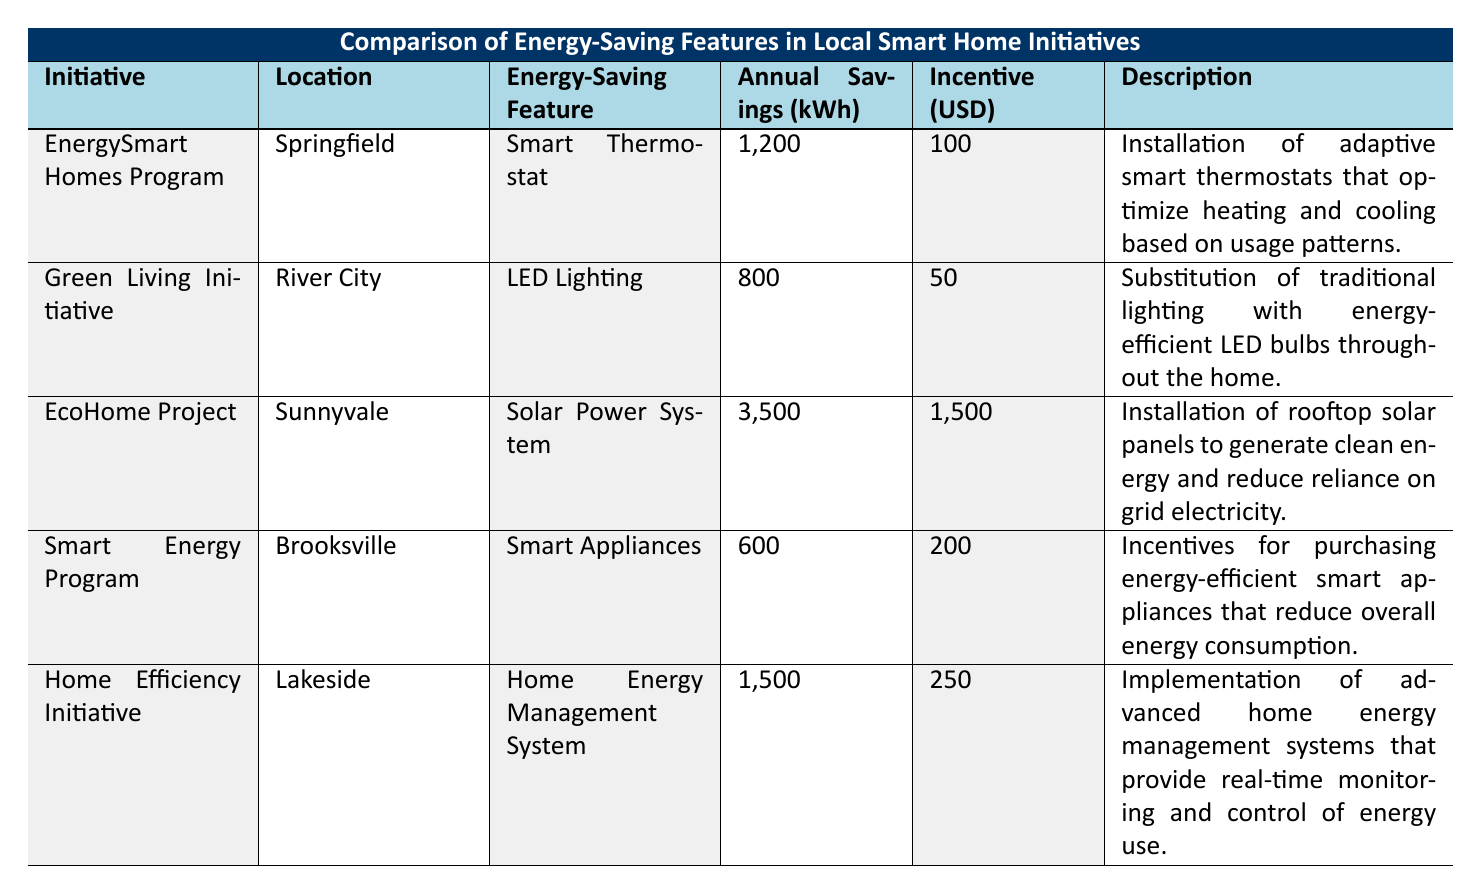What is the annual energy savings for the EcoHome Project? The table shows that the EcoHome Project provides annual savings of 3500 kWh.
Answer: 3500 kWh Which location has the highest incentive amount? By comparing the incentive amounts listed, the EcoHome Project in Sunnyvale offers the highest incentive of 1500 USD.
Answer: Sunnyvale How much energy savings is achieved by the Home Efficiency Initiative compared to the Smart Energy Program? The Home Efficiency Initiative saves 1500 kWh, while the Smart Energy Program saves 600 kWh. The difference is 1500 - 600 = 900 kWh.
Answer: 900 kWh Is the annual savings for the Green Living Initiative less than 1000 kWh? The annual savings for the Green Living Initiative is 800 kWh, which is indeed less than 1000 kWh.
Answer: Yes What is the average annual savings of the energy-saving features listed in the table? The total annual savings are 1200 + 800 + 3500 + 600 + 1500 = 6600 kWh. There are 5 initiatives, so the average is 6600 / 5 = 1320 kWh.
Answer: 1320 kWh Does the Smart Appliances feature offer the least annual savings? The Smart Appliances feature offers annual savings of 600 kWh, which is less than any other feature listed in the table.
Answer: Yes What is the total amount of incentives for all initiatives combined? Adding up the incentives: 100 + 50 + 1500 + 200 + 250 = 2100 USD gives the total incentive amount.
Answer: 2100 USD Which initiative offers a home energy management system? The Home Efficiency Initiative provides a Home Energy Management System as its energy-saving feature.
Answer: Home Efficiency Initiative How many initiatives listed provide an annual saving of more than 1000 kWh? The initiatives that save more than 1000 kWh are the EcoHome Project (3500 kWh) and the Home Efficiency Initiative (1500 kWh). Thus, there are 2 such initiatives.
Answer: 2 